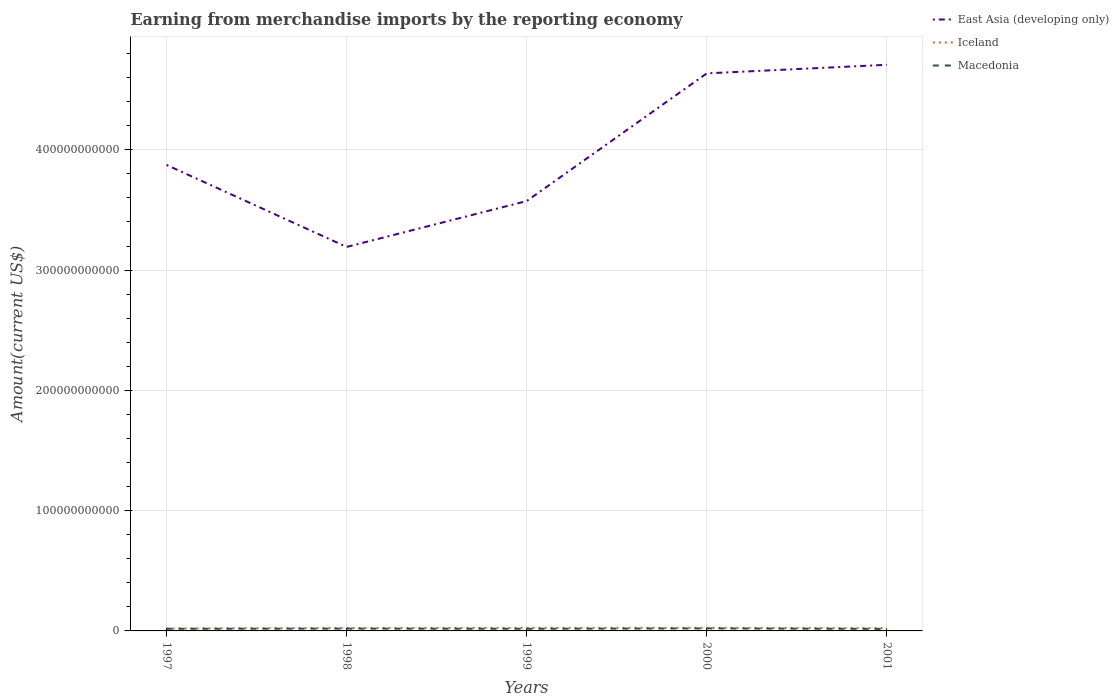How many different coloured lines are there?
Keep it short and to the point. 3. Does the line corresponding to Iceland intersect with the line corresponding to East Asia (developing only)?
Ensure brevity in your answer.  No. Is the number of lines equal to the number of legend labels?
Your answer should be compact. Yes. Across all years, what is the maximum amount earned from merchandise imports in East Asia (developing only)?
Your answer should be compact. 3.19e+11. In which year was the amount earned from merchandise imports in East Asia (developing only) maximum?
Offer a terse response. 1998. What is the total amount earned from merchandise imports in Macedonia in the graph?
Your response must be concise. -3.11e+08. What is the difference between the highest and the second highest amount earned from merchandise imports in Iceland?
Make the answer very short. 5.40e+08. How many lines are there?
Your answer should be compact. 3. How many years are there in the graph?
Your answer should be very brief. 5. What is the difference between two consecutive major ticks on the Y-axis?
Offer a very short reply. 1.00e+11. Are the values on the major ticks of Y-axis written in scientific E-notation?
Provide a short and direct response. No. Does the graph contain any zero values?
Provide a succinct answer. No. Does the graph contain grids?
Ensure brevity in your answer.  Yes. How many legend labels are there?
Offer a very short reply. 3. What is the title of the graph?
Ensure brevity in your answer.  Earning from merchandise imports by the reporting economy. What is the label or title of the X-axis?
Make the answer very short. Years. What is the label or title of the Y-axis?
Provide a short and direct response. Amount(current US$). What is the Amount(current US$) in East Asia (developing only) in 1997?
Your answer should be very brief. 3.87e+11. What is the Amount(current US$) of Iceland in 1997?
Make the answer very short. 2.05e+09. What is the Amount(current US$) of Macedonia in 1997?
Your answer should be compact. 1.77e+09. What is the Amount(current US$) of East Asia (developing only) in 1998?
Give a very brief answer. 3.19e+11. What is the Amount(current US$) in Iceland in 1998?
Provide a short and direct response. 2.46e+09. What is the Amount(current US$) in Macedonia in 1998?
Your response must be concise. 1.91e+09. What is the Amount(current US$) in East Asia (developing only) in 1999?
Offer a very short reply. 3.57e+11. What is the Amount(current US$) in Iceland in 1999?
Your answer should be very brief. 2.52e+09. What is the Amount(current US$) of Macedonia in 1999?
Your answer should be compact. 1.80e+09. What is the Amount(current US$) of East Asia (developing only) in 2000?
Provide a short and direct response. 4.64e+11. What is the Amount(current US$) in Iceland in 2000?
Ensure brevity in your answer.  2.59e+09. What is the Amount(current US$) of Macedonia in 2000?
Offer a terse response. 2.08e+09. What is the Amount(current US$) of East Asia (developing only) in 2001?
Offer a terse response. 4.71e+11. What is the Amount(current US$) of Iceland in 2001?
Provide a short and direct response. 2.28e+09. What is the Amount(current US$) in Macedonia in 2001?
Keep it short and to the point. 1.69e+09. Across all years, what is the maximum Amount(current US$) of East Asia (developing only)?
Make the answer very short. 4.71e+11. Across all years, what is the maximum Amount(current US$) of Iceland?
Offer a terse response. 2.59e+09. Across all years, what is the maximum Amount(current US$) in Macedonia?
Your answer should be very brief. 2.08e+09. Across all years, what is the minimum Amount(current US$) in East Asia (developing only)?
Your answer should be very brief. 3.19e+11. Across all years, what is the minimum Amount(current US$) in Iceland?
Your answer should be very brief. 2.05e+09. Across all years, what is the minimum Amount(current US$) of Macedonia?
Offer a very short reply. 1.69e+09. What is the total Amount(current US$) in East Asia (developing only) in the graph?
Give a very brief answer. 2.00e+12. What is the total Amount(current US$) of Iceland in the graph?
Give a very brief answer. 1.19e+1. What is the total Amount(current US$) in Macedonia in the graph?
Make the answer very short. 9.26e+09. What is the difference between the Amount(current US$) of East Asia (developing only) in 1997 and that in 1998?
Your answer should be very brief. 6.81e+1. What is the difference between the Amount(current US$) in Iceland in 1997 and that in 1998?
Give a very brief answer. -4.17e+08. What is the difference between the Amount(current US$) of Macedonia in 1997 and that in 1998?
Keep it short and to the point. -1.41e+08. What is the difference between the Amount(current US$) of East Asia (developing only) in 1997 and that in 1999?
Provide a short and direct response. 3.00e+1. What is the difference between the Amount(current US$) of Iceland in 1997 and that in 1999?
Offer a very short reply. -4.71e+08. What is the difference between the Amount(current US$) in Macedonia in 1997 and that in 1999?
Provide a short and direct response. -2.29e+07. What is the difference between the Amount(current US$) of East Asia (developing only) in 1997 and that in 2000?
Make the answer very short. -7.61e+1. What is the difference between the Amount(current US$) in Iceland in 1997 and that in 2000?
Provide a short and direct response. -5.40e+08. What is the difference between the Amount(current US$) in Macedonia in 1997 and that in 2000?
Make the answer very short. -3.11e+08. What is the difference between the Amount(current US$) of East Asia (developing only) in 1997 and that in 2001?
Give a very brief answer. -8.33e+1. What is the difference between the Amount(current US$) in Iceland in 1997 and that in 2001?
Offer a very short reply. -2.29e+08. What is the difference between the Amount(current US$) of Macedonia in 1997 and that in 2001?
Give a very brief answer. 8.59e+07. What is the difference between the Amount(current US$) in East Asia (developing only) in 1998 and that in 1999?
Give a very brief answer. -3.81e+1. What is the difference between the Amount(current US$) of Iceland in 1998 and that in 1999?
Keep it short and to the point. -5.42e+07. What is the difference between the Amount(current US$) in Macedonia in 1998 and that in 1999?
Offer a very short reply. 1.18e+08. What is the difference between the Amount(current US$) of East Asia (developing only) in 1998 and that in 2000?
Provide a short and direct response. -1.44e+11. What is the difference between the Amount(current US$) in Iceland in 1998 and that in 2000?
Keep it short and to the point. -1.22e+08. What is the difference between the Amount(current US$) of Macedonia in 1998 and that in 2000?
Your answer should be compact. -1.70e+08. What is the difference between the Amount(current US$) in East Asia (developing only) in 1998 and that in 2001?
Your response must be concise. -1.51e+11. What is the difference between the Amount(current US$) in Iceland in 1998 and that in 2001?
Offer a very short reply. 1.88e+08. What is the difference between the Amount(current US$) in Macedonia in 1998 and that in 2001?
Make the answer very short. 2.27e+08. What is the difference between the Amount(current US$) in East Asia (developing only) in 1999 and that in 2000?
Offer a terse response. -1.06e+11. What is the difference between the Amount(current US$) in Iceland in 1999 and that in 2000?
Provide a short and direct response. -6.83e+07. What is the difference between the Amount(current US$) in Macedonia in 1999 and that in 2000?
Your response must be concise. -2.88e+08. What is the difference between the Amount(current US$) of East Asia (developing only) in 1999 and that in 2001?
Ensure brevity in your answer.  -1.13e+11. What is the difference between the Amount(current US$) of Iceland in 1999 and that in 2001?
Offer a terse response. 2.42e+08. What is the difference between the Amount(current US$) in Macedonia in 1999 and that in 2001?
Offer a very short reply. 1.09e+08. What is the difference between the Amount(current US$) of East Asia (developing only) in 2000 and that in 2001?
Ensure brevity in your answer.  -7.15e+09. What is the difference between the Amount(current US$) in Iceland in 2000 and that in 2001?
Your answer should be compact. 3.10e+08. What is the difference between the Amount(current US$) of Macedonia in 2000 and that in 2001?
Ensure brevity in your answer.  3.97e+08. What is the difference between the Amount(current US$) in East Asia (developing only) in 1997 and the Amount(current US$) in Iceland in 1998?
Provide a succinct answer. 3.85e+11. What is the difference between the Amount(current US$) of East Asia (developing only) in 1997 and the Amount(current US$) of Macedonia in 1998?
Your answer should be compact. 3.85e+11. What is the difference between the Amount(current US$) of Iceland in 1997 and the Amount(current US$) of Macedonia in 1998?
Keep it short and to the point. 1.31e+08. What is the difference between the Amount(current US$) of East Asia (developing only) in 1997 and the Amount(current US$) of Iceland in 1999?
Your response must be concise. 3.85e+11. What is the difference between the Amount(current US$) in East Asia (developing only) in 1997 and the Amount(current US$) in Macedonia in 1999?
Offer a very short reply. 3.86e+11. What is the difference between the Amount(current US$) in Iceland in 1997 and the Amount(current US$) in Macedonia in 1999?
Ensure brevity in your answer.  2.50e+08. What is the difference between the Amount(current US$) of East Asia (developing only) in 1997 and the Amount(current US$) of Iceland in 2000?
Ensure brevity in your answer.  3.85e+11. What is the difference between the Amount(current US$) in East Asia (developing only) in 1997 and the Amount(current US$) in Macedonia in 2000?
Your answer should be very brief. 3.85e+11. What is the difference between the Amount(current US$) of Iceland in 1997 and the Amount(current US$) of Macedonia in 2000?
Keep it short and to the point. -3.86e+07. What is the difference between the Amount(current US$) of East Asia (developing only) in 1997 and the Amount(current US$) of Iceland in 2001?
Your answer should be very brief. 3.85e+11. What is the difference between the Amount(current US$) of East Asia (developing only) in 1997 and the Amount(current US$) of Macedonia in 2001?
Your answer should be compact. 3.86e+11. What is the difference between the Amount(current US$) of Iceland in 1997 and the Amount(current US$) of Macedonia in 2001?
Provide a succinct answer. 3.59e+08. What is the difference between the Amount(current US$) in East Asia (developing only) in 1998 and the Amount(current US$) in Iceland in 1999?
Provide a succinct answer. 3.17e+11. What is the difference between the Amount(current US$) in East Asia (developing only) in 1998 and the Amount(current US$) in Macedonia in 1999?
Keep it short and to the point. 3.17e+11. What is the difference between the Amount(current US$) in Iceland in 1998 and the Amount(current US$) in Macedonia in 1999?
Offer a terse response. 6.67e+08. What is the difference between the Amount(current US$) of East Asia (developing only) in 1998 and the Amount(current US$) of Iceland in 2000?
Keep it short and to the point. 3.17e+11. What is the difference between the Amount(current US$) in East Asia (developing only) in 1998 and the Amount(current US$) in Macedonia in 2000?
Offer a very short reply. 3.17e+11. What is the difference between the Amount(current US$) of Iceland in 1998 and the Amount(current US$) of Macedonia in 2000?
Your response must be concise. 3.78e+08. What is the difference between the Amount(current US$) of East Asia (developing only) in 1998 and the Amount(current US$) of Iceland in 2001?
Give a very brief answer. 3.17e+11. What is the difference between the Amount(current US$) of East Asia (developing only) in 1998 and the Amount(current US$) of Macedonia in 2001?
Your answer should be compact. 3.18e+11. What is the difference between the Amount(current US$) of Iceland in 1998 and the Amount(current US$) of Macedonia in 2001?
Keep it short and to the point. 7.76e+08. What is the difference between the Amount(current US$) in East Asia (developing only) in 1999 and the Amount(current US$) in Iceland in 2000?
Give a very brief answer. 3.55e+11. What is the difference between the Amount(current US$) of East Asia (developing only) in 1999 and the Amount(current US$) of Macedonia in 2000?
Make the answer very short. 3.55e+11. What is the difference between the Amount(current US$) of Iceland in 1999 and the Amount(current US$) of Macedonia in 2000?
Give a very brief answer. 4.33e+08. What is the difference between the Amount(current US$) of East Asia (developing only) in 1999 and the Amount(current US$) of Iceland in 2001?
Keep it short and to the point. 3.55e+11. What is the difference between the Amount(current US$) in East Asia (developing only) in 1999 and the Amount(current US$) in Macedonia in 2001?
Provide a succinct answer. 3.56e+11. What is the difference between the Amount(current US$) in Iceland in 1999 and the Amount(current US$) in Macedonia in 2001?
Your response must be concise. 8.30e+08. What is the difference between the Amount(current US$) in East Asia (developing only) in 2000 and the Amount(current US$) in Iceland in 2001?
Your response must be concise. 4.61e+11. What is the difference between the Amount(current US$) of East Asia (developing only) in 2000 and the Amount(current US$) of Macedonia in 2001?
Make the answer very short. 4.62e+11. What is the difference between the Amount(current US$) in Iceland in 2000 and the Amount(current US$) in Macedonia in 2001?
Keep it short and to the point. 8.98e+08. What is the average Amount(current US$) in East Asia (developing only) per year?
Provide a succinct answer. 4.00e+11. What is the average Amount(current US$) of Iceland per year?
Provide a succinct answer. 2.38e+09. What is the average Amount(current US$) of Macedonia per year?
Ensure brevity in your answer.  1.85e+09. In the year 1997, what is the difference between the Amount(current US$) in East Asia (developing only) and Amount(current US$) in Iceland?
Give a very brief answer. 3.85e+11. In the year 1997, what is the difference between the Amount(current US$) in East Asia (developing only) and Amount(current US$) in Macedonia?
Your answer should be compact. 3.86e+11. In the year 1997, what is the difference between the Amount(current US$) in Iceland and Amount(current US$) in Macedonia?
Keep it short and to the point. 2.73e+08. In the year 1998, what is the difference between the Amount(current US$) in East Asia (developing only) and Amount(current US$) in Iceland?
Make the answer very short. 3.17e+11. In the year 1998, what is the difference between the Amount(current US$) of East Asia (developing only) and Amount(current US$) of Macedonia?
Provide a succinct answer. 3.17e+11. In the year 1998, what is the difference between the Amount(current US$) of Iceland and Amount(current US$) of Macedonia?
Offer a terse response. 5.48e+08. In the year 1999, what is the difference between the Amount(current US$) of East Asia (developing only) and Amount(current US$) of Iceland?
Ensure brevity in your answer.  3.55e+11. In the year 1999, what is the difference between the Amount(current US$) in East Asia (developing only) and Amount(current US$) in Macedonia?
Keep it short and to the point. 3.56e+11. In the year 1999, what is the difference between the Amount(current US$) in Iceland and Amount(current US$) in Macedonia?
Offer a very short reply. 7.21e+08. In the year 2000, what is the difference between the Amount(current US$) of East Asia (developing only) and Amount(current US$) of Iceland?
Provide a short and direct response. 4.61e+11. In the year 2000, what is the difference between the Amount(current US$) of East Asia (developing only) and Amount(current US$) of Macedonia?
Offer a very short reply. 4.61e+11. In the year 2000, what is the difference between the Amount(current US$) of Iceland and Amount(current US$) of Macedonia?
Ensure brevity in your answer.  5.01e+08. In the year 2001, what is the difference between the Amount(current US$) in East Asia (developing only) and Amount(current US$) in Iceland?
Make the answer very short. 4.68e+11. In the year 2001, what is the difference between the Amount(current US$) of East Asia (developing only) and Amount(current US$) of Macedonia?
Your response must be concise. 4.69e+11. In the year 2001, what is the difference between the Amount(current US$) of Iceland and Amount(current US$) of Macedonia?
Your response must be concise. 5.88e+08. What is the ratio of the Amount(current US$) in East Asia (developing only) in 1997 to that in 1998?
Make the answer very short. 1.21. What is the ratio of the Amount(current US$) of Iceland in 1997 to that in 1998?
Your response must be concise. 0.83. What is the ratio of the Amount(current US$) of Macedonia in 1997 to that in 1998?
Offer a terse response. 0.93. What is the ratio of the Amount(current US$) of East Asia (developing only) in 1997 to that in 1999?
Keep it short and to the point. 1.08. What is the ratio of the Amount(current US$) of Iceland in 1997 to that in 1999?
Make the answer very short. 0.81. What is the ratio of the Amount(current US$) of Macedonia in 1997 to that in 1999?
Ensure brevity in your answer.  0.99. What is the ratio of the Amount(current US$) of East Asia (developing only) in 1997 to that in 2000?
Your answer should be very brief. 0.84. What is the ratio of the Amount(current US$) of Iceland in 1997 to that in 2000?
Ensure brevity in your answer.  0.79. What is the ratio of the Amount(current US$) of Macedonia in 1997 to that in 2000?
Provide a short and direct response. 0.85. What is the ratio of the Amount(current US$) of East Asia (developing only) in 1997 to that in 2001?
Give a very brief answer. 0.82. What is the ratio of the Amount(current US$) of Iceland in 1997 to that in 2001?
Offer a very short reply. 0.9. What is the ratio of the Amount(current US$) in Macedonia in 1997 to that in 2001?
Provide a short and direct response. 1.05. What is the ratio of the Amount(current US$) of East Asia (developing only) in 1998 to that in 1999?
Make the answer very short. 0.89. What is the ratio of the Amount(current US$) in Iceland in 1998 to that in 1999?
Your response must be concise. 0.98. What is the ratio of the Amount(current US$) of Macedonia in 1998 to that in 1999?
Your response must be concise. 1.07. What is the ratio of the Amount(current US$) in East Asia (developing only) in 1998 to that in 2000?
Make the answer very short. 0.69. What is the ratio of the Amount(current US$) of Iceland in 1998 to that in 2000?
Your answer should be compact. 0.95. What is the ratio of the Amount(current US$) in Macedonia in 1998 to that in 2000?
Ensure brevity in your answer.  0.92. What is the ratio of the Amount(current US$) of East Asia (developing only) in 1998 to that in 2001?
Offer a very short reply. 0.68. What is the ratio of the Amount(current US$) of Iceland in 1998 to that in 2001?
Your answer should be compact. 1.08. What is the ratio of the Amount(current US$) in Macedonia in 1998 to that in 2001?
Make the answer very short. 1.13. What is the ratio of the Amount(current US$) in East Asia (developing only) in 1999 to that in 2000?
Your response must be concise. 0.77. What is the ratio of the Amount(current US$) of Iceland in 1999 to that in 2000?
Make the answer very short. 0.97. What is the ratio of the Amount(current US$) of Macedonia in 1999 to that in 2000?
Give a very brief answer. 0.86. What is the ratio of the Amount(current US$) of East Asia (developing only) in 1999 to that in 2001?
Your answer should be compact. 0.76. What is the ratio of the Amount(current US$) in Iceland in 1999 to that in 2001?
Your answer should be very brief. 1.11. What is the ratio of the Amount(current US$) of Macedonia in 1999 to that in 2001?
Your answer should be very brief. 1.06. What is the ratio of the Amount(current US$) in Iceland in 2000 to that in 2001?
Make the answer very short. 1.14. What is the ratio of the Amount(current US$) in Macedonia in 2000 to that in 2001?
Your answer should be very brief. 1.24. What is the difference between the highest and the second highest Amount(current US$) of East Asia (developing only)?
Give a very brief answer. 7.15e+09. What is the difference between the highest and the second highest Amount(current US$) in Iceland?
Offer a terse response. 6.83e+07. What is the difference between the highest and the second highest Amount(current US$) in Macedonia?
Your answer should be compact. 1.70e+08. What is the difference between the highest and the lowest Amount(current US$) of East Asia (developing only)?
Your answer should be very brief. 1.51e+11. What is the difference between the highest and the lowest Amount(current US$) of Iceland?
Offer a very short reply. 5.40e+08. What is the difference between the highest and the lowest Amount(current US$) of Macedonia?
Give a very brief answer. 3.97e+08. 